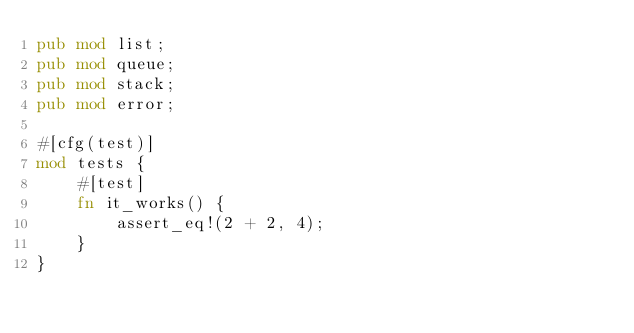<code> <loc_0><loc_0><loc_500><loc_500><_Rust_>pub mod list;
pub mod queue;
pub mod stack;
pub mod error;

#[cfg(test)]
mod tests {
    #[test]
    fn it_works() {
        assert_eq!(2 + 2, 4);
    }
}
</code> 